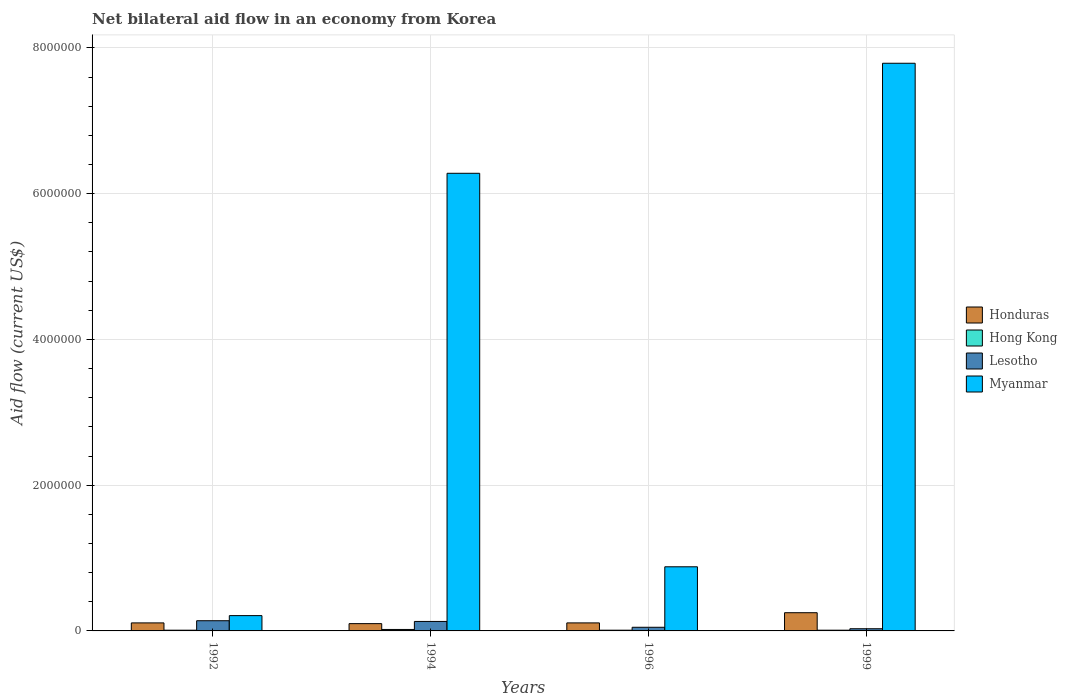How many bars are there on the 3rd tick from the left?
Ensure brevity in your answer.  4. What is the label of the 1st group of bars from the left?
Offer a terse response. 1992. What is the net bilateral aid flow in Myanmar in 1999?
Ensure brevity in your answer.  7.79e+06. Across all years, what is the minimum net bilateral aid flow in Hong Kong?
Your response must be concise. 10000. What is the total net bilateral aid flow in Hong Kong in the graph?
Give a very brief answer. 5.00e+04. What is the difference between the net bilateral aid flow in Hong Kong in 1992 and that in 1996?
Your answer should be compact. 0. What is the difference between the net bilateral aid flow in Hong Kong in 1992 and the net bilateral aid flow in Myanmar in 1999?
Make the answer very short. -7.78e+06. What is the average net bilateral aid flow in Myanmar per year?
Keep it short and to the point. 3.79e+06. What is the ratio of the net bilateral aid flow in Lesotho in 1994 to that in 1999?
Make the answer very short. 4.33. Is the net bilateral aid flow in Hong Kong in 1992 less than that in 1996?
Give a very brief answer. No. What is the difference between the highest and the second highest net bilateral aid flow in Myanmar?
Give a very brief answer. 1.51e+06. Is the sum of the net bilateral aid flow in Honduras in 1994 and 1999 greater than the maximum net bilateral aid flow in Lesotho across all years?
Your response must be concise. Yes. What does the 1st bar from the left in 1994 represents?
Give a very brief answer. Honduras. What does the 4th bar from the right in 1996 represents?
Offer a very short reply. Honduras. How many bars are there?
Make the answer very short. 16. What is the difference between two consecutive major ticks on the Y-axis?
Keep it short and to the point. 2.00e+06. Does the graph contain any zero values?
Give a very brief answer. No. Does the graph contain grids?
Offer a terse response. Yes. Where does the legend appear in the graph?
Offer a very short reply. Center right. How are the legend labels stacked?
Your answer should be very brief. Vertical. What is the title of the graph?
Your response must be concise. Net bilateral aid flow in an economy from Korea. What is the label or title of the X-axis?
Provide a succinct answer. Years. What is the label or title of the Y-axis?
Offer a terse response. Aid flow (current US$). What is the Aid flow (current US$) in Honduras in 1992?
Your answer should be very brief. 1.10e+05. What is the Aid flow (current US$) of Hong Kong in 1992?
Provide a succinct answer. 10000. What is the Aid flow (current US$) in Lesotho in 1992?
Offer a terse response. 1.40e+05. What is the Aid flow (current US$) in Myanmar in 1992?
Provide a short and direct response. 2.10e+05. What is the Aid flow (current US$) in Honduras in 1994?
Provide a succinct answer. 1.00e+05. What is the Aid flow (current US$) in Hong Kong in 1994?
Ensure brevity in your answer.  2.00e+04. What is the Aid flow (current US$) of Myanmar in 1994?
Provide a succinct answer. 6.28e+06. What is the Aid flow (current US$) in Honduras in 1996?
Keep it short and to the point. 1.10e+05. What is the Aid flow (current US$) in Lesotho in 1996?
Keep it short and to the point. 5.00e+04. What is the Aid flow (current US$) in Myanmar in 1996?
Keep it short and to the point. 8.80e+05. What is the Aid flow (current US$) in Honduras in 1999?
Your answer should be compact. 2.50e+05. What is the Aid flow (current US$) in Hong Kong in 1999?
Provide a short and direct response. 10000. What is the Aid flow (current US$) of Myanmar in 1999?
Make the answer very short. 7.79e+06. Across all years, what is the maximum Aid flow (current US$) in Honduras?
Keep it short and to the point. 2.50e+05. Across all years, what is the maximum Aid flow (current US$) of Hong Kong?
Make the answer very short. 2.00e+04. Across all years, what is the maximum Aid flow (current US$) in Myanmar?
Give a very brief answer. 7.79e+06. Across all years, what is the minimum Aid flow (current US$) in Honduras?
Provide a short and direct response. 1.00e+05. Across all years, what is the minimum Aid flow (current US$) in Hong Kong?
Give a very brief answer. 10000. Across all years, what is the minimum Aid flow (current US$) of Lesotho?
Give a very brief answer. 3.00e+04. What is the total Aid flow (current US$) in Honduras in the graph?
Keep it short and to the point. 5.70e+05. What is the total Aid flow (current US$) of Hong Kong in the graph?
Give a very brief answer. 5.00e+04. What is the total Aid flow (current US$) of Myanmar in the graph?
Offer a very short reply. 1.52e+07. What is the difference between the Aid flow (current US$) in Honduras in 1992 and that in 1994?
Give a very brief answer. 10000. What is the difference between the Aid flow (current US$) of Myanmar in 1992 and that in 1994?
Ensure brevity in your answer.  -6.07e+06. What is the difference between the Aid flow (current US$) of Hong Kong in 1992 and that in 1996?
Give a very brief answer. 0. What is the difference between the Aid flow (current US$) of Lesotho in 1992 and that in 1996?
Offer a very short reply. 9.00e+04. What is the difference between the Aid flow (current US$) of Myanmar in 1992 and that in 1996?
Offer a very short reply. -6.70e+05. What is the difference between the Aid flow (current US$) in Honduras in 1992 and that in 1999?
Your answer should be very brief. -1.40e+05. What is the difference between the Aid flow (current US$) of Myanmar in 1992 and that in 1999?
Ensure brevity in your answer.  -7.58e+06. What is the difference between the Aid flow (current US$) in Myanmar in 1994 and that in 1996?
Offer a very short reply. 5.40e+06. What is the difference between the Aid flow (current US$) of Hong Kong in 1994 and that in 1999?
Make the answer very short. 10000. What is the difference between the Aid flow (current US$) of Lesotho in 1994 and that in 1999?
Provide a succinct answer. 1.00e+05. What is the difference between the Aid flow (current US$) in Myanmar in 1994 and that in 1999?
Offer a terse response. -1.51e+06. What is the difference between the Aid flow (current US$) of Myanmar in 1996 and that in 1999?
Your answer should be compact. -6.91e+06. What is the difference between the Aid flow (current US$) in Honduras in 1992 and the Aid flow (current US$) in Hong Kong in 1994?
Ensure brevity in your answer.  9.00e+04. What is the difference between the Aid flow (current US$) in Honduras in 1992 and the Aid flow (current US$) in Lesotho in 1994?
Offer a very short reply. -2.00e+04. What is the difference between the Aid flow (current US$) of Honduras in 1992 and the Aid flow (current US$) of Myanmar in 1994?
Provide a short and direct response. -6.17e+06. What is the difference between the Aid flow (current US$) in Hong Kong in 1992 and the Aid flow (current US$) in Lesotho in 1994?
Provide a succinct answer. -1.20e+05. What is the difference between the Aid flow (current US$) in Hong Kong in 1992 and the Aid flow (current US$) in Myanmar in 1994?
Your answer should be compact. -6.27e+06. What is the difference between the Aid flow (current US$) in Lesotho in 1992 and the Aid flow (current US$) in Myanmar in 1994?
Provide a succinct answer. -6.14e+06. What is the difference between the Aid flow (current US$) in Honduras in 1992 and the Aid flow (current US$) in Hong Kong in 1996?
Your answer should be compact. 1.00e+05. What is the difference between the Aid flow (current US$) of Honduras in 1992 and the Aid flow (current US$) of Lesotho in 1996?
Ensure brevity in your answer.  6.00e+04. What is the difference between the Aid flow (current US$) in Honduras in 1992 and the Aid flow (current US$) in Myanmar in 1996?
Offer a terse response. -7.70e+05. What is the difference between the Aid flow (current US$) of Hong Kong in 1992 and the Aid flow (current US$) of Lesotho in 1996?
Provide a succinct answer. -4.00e+04. What is the difference between the Aid flow (current US$) in Hong Kong in 1992 and the Aid flow (current US$) in Myanmar in 1996?
Ensure brevity in your answer.  -8.70e+05. What is the difference between the Aid flow (current US$) in Lesotho in 1992 and the Aid flow (current US$) in Myanmar in 1996?
Give a very brief answer. -7.40e+05. What is the difference between the Aid flow (current US$) in Honduras in 1992 and the Aid flow (current US$) in Hong Kong in 1999?
Your response must be concise. 1.00e+05. What is the difference between the Aid flow (current US$) in Honduras in 1992 and the Aid flow (current US$) in Myanmar in 1999?
Your response must be concise. -7.68e+06. What is the difference between the Aid flow (current US$) in Hong Kong in 1992 and the Aid flow (current US$) in Myanmar in 1999?
Your response must be concise. -7.78e+06. What is the difference between the Aid flow (current US$) in Lesotho in 1992 and the Aid flow (current US$) in Myanmar in 1999?
Offer a very short reply. -7.65e+06. What is the difference between the Aid flow (current US$) of Honduras in 1994 and the Aid flow (current US$) of Lesotho in 1996?
Keep it short and to the point. 5.00e+04. What is the difference between the Aid flow (current US$) in Honduras in 1994 and the Aid flow (current US$) in Myanmar in 1996?
Provide a short and direct response. -7.80e+05. What is the difference between the Aid flow (current US$) of Hong Kong in 1994 and the Aid flow (current US$) of Myanmar in 1996?
Keep it short and to the point. -8.60e+05. What is the difference between the Aid flow (current US$) in Lesotho in 1994 and the Aid flow (current US$) in Myanmar in 1996?
Your response must be concise. -7.50e+05. What is the difference between the Aid flow (current US$) in Honduras in 1994 and the Aid flow (current US$) in Lesotho in 1999?
Keep it short and to the point. 7.00e+04. What is the difference between the Aid flow (current US$) in Honduras in 1994 and the Aid flow (current US$) in Myanmar in 1999?
Give a very brief answer. -7.69e+06. What is the difference between the Aid flow (current US$) of Hong Kong in 1994 and the Aid flow (current US$) of Lesotho in 1999?
Make the answer very short. -10000. What is the difference between the Aid flow (current US$) in Hong Kong in 1994 and the Aid flow (current US$) in Myanmar in 1999?
Offer a very short reply. -7.77e+06. What is the difference between the Aid flow (current US$) of Lesotho in 1994 and the Aid flow (current US$) of Myanmar in 1999?
Ensure brevity in your answer.  -7.66e+06. What is the difference between the Aid flow (current US$) in Honduras in 1996 and the Aid flow (current US$) in Hong Kong in 1999?
Keep it short and to the point. 1.00e+05. What is the difference between the Aid flow (current US$) in Honduras in 1996 and the Aid flow (current US$) in Myanmar in 1999?
Your answer should be very brief. -7.68e+06. What is the difference between the Aid flow (current US$) in Hong Kong in 1996 and the Aid flow (current US$) in Lesotho in 1999?
Keep it short and to the point. -2.00e+04. What is the difference between the Aid flow (current US$) in Hong Kong in 1996 and the Aid flow (current US$) in Myanmar in 1999?
Ensure brevity in your answer.  -7.78e+06. What is the difference between the Aid flow (current US$) in Lesotho in 1996 and the Aid flow (current US$) in Myanmar in 1999?
Offer a very short reply. -7.74e+06. What is the average Aid flow (current US$) in Honduras per year?
Your response must be concise. 1.42e+05. What is the average Aid flow (current US$) of Hong Kong per year?
Provide a succinct answer. 1.25e+04. What is the average Aid flow (current US$) of Lesotho per year?
Ensure brevity in your answer.  8.75e+04. What is the average Aid flow (current US$) of Myanmar per year?
Offer a very short reply. 3.79e+06. In the year 1992, what is the difference between the Aid flow (current US$) of Honduras and Aid flow (current US$) of Hong Kong?
Offer a very short reply. 1.00e+05. In the year 1992, what is the difference between the Aid flow (current US$) in Honduras and Aid flow (current US$) in Lesotho?
Give a very brief answer. -3.00e+04. In the year 1992, what is the difference between the Aid flow (current US$) in Hong Kong and Aid flow (current US$) in Lesotho?
Make the answer very short. -1.30e+05. In the year 1992, what is the difference between the Aid flow (current US$) of Hong Kong and Aid flow (current US$) of Myanmar?
Offer a terse response. -2.00e+05. In the year 1994, what is the difference between the Aid flow (current US$) of Honduras and Aid flow (current US$) of Myanmar?
Provide a succinct answer. -6.18e+06. In the year 1994, what is the difference between the Aid flow (current US$) of Hong Kong and Aid flow (current US$) of Myanmar?
Make the answer very short. -6.26e+06. In the year 1994, what is the difference between the Aid flow (current US$) of Lesotho and Aid flow (current US$) of Myanmar?
Give a very brief answer. -6.15e+06. In the year 1996, what is the difference between the Aid flow (current US$) in Honduras and Aid flow (current US$) in Lesotho?
Your answer should be very brief. 6.00e+04. In the year 1996, what is the difference between the Aid flow (current US$) of Honduras and Aid flow (current US$) of Myanmar?
Your answer should be very brief. -7.70e+05. In the year 1996, what is the difference between the Aid flow (current US$) in Hong Kong and Aid flow (current US$) in Myanmar?
Your answer should be compact. -8.70e+05. In the year 1996, what is the difference between the Aid flow (current US$) in Lesotho and Aid flow (current US$) in Myanmar?
Keep it short and to the point. -8.30e+05. In the year 1999, what is the difference between the Aid flow (current US$) of Honduras and Aid flow (current US$) of Myanmar?
Keep it short and to the point. -7.54e+06. In the year 1999, what is the difference between the Aid flow (current US$) of Hong Kong and Aid flow (current US$) of Myanmar?
Offer a very short reply. -7.78e+06. In the year 1999, what is the difference between the Aid flow (current US$) in Lesotho and Aid flow (current US$) in Myanmar?
Give a very brief answer. -7.76e+06. What is the ratio of the Aid flow (current US$) in Honduras in 1992 to that in 1994?
Keep it short and to the point. 1.1. What is the ratio of the Aid flow (current US$) in Myanmar in 1992 to that in 1994?
Keep it short and to the point. 0.03. What is the ratio of the Aid flow (current US$) of Honduras in 1992 to that in 1996?
Keep it short and to the point. 1. What is the ratio of the Aid flow (current US$) in Hong Kong in 1992 to that in 1996?
Offer a terse response. 1. What is the ratio of the Aid flow (current US$) of Lesotho in 1992 to that in 1996?
Keep it short and to the point. 2.8. What is the ratio of the Aid flow (current US$) of Myanmar in 1992 to that in 1996?
Your answer should be very brief. 0.24. What is the ratio of the Aid flow (current US$) of Honduras in 1992 to that in 1999?
Offer a very short reply. 0.44. What is the ratio of the Aid flow (current US$) in Hong Kong in 1992 to that in 1999?
Keep it short and to the point. 1. What is the ratio of the Aid flow (current US$) of Lesotho in 1992 to that in 1999?
Make the answer very short. 4.67. What is the ratio of the Aid flow (current US$) in Myanmar in 1992 to that in 1999?
Provide a succinct answer. 0.03. What is the ratio of the Aid flow (current US$) of Honduras in 1994 to that in 1996?
Ensure brevity in your answer.  0.91. What is the ratio of the Aid flow (current US$) in Hong Kong in 1994 to that in 1996?
Offer a very short reply. 2. What is the ratio of the Aid flow (current US$) in Myanmar in 1994 to that in 1996?
Keep it short and to the point. 7.14. What is the ratio of the Aid flow (current US$) of Lesotho in 1994 to that in 1999?
Your answer should be very brief. 4.33. What is the ratio of the Aid flow (current US$) of Myanmar in 1994 to that in 1999?
Offer a terse response. 0.81. What is the ratio of the Aid flow (current US$) in Honduras in 1996 to that in 1999?
Provide a short and direct response. 0.44. What is the ratio of the Aid flow (current US$) of Myanmar in 1996 to that in 1999?
Your response must be concise. 0.11. What is the difference between the highest and the second highest Aid flow (current US$) in Honduras?
Keep it short and to the point. 1.40e+05. What is the difference between the highest and the second highest Aid flow (current US$) in Hong Kong?
Your response must be concise. 10000. What is the difference between the highest and the second highest Aid flow (current US$) in Lesotho?
Provide a short and direct response. 10000. What is the difference between the highest and the second highest Aid flow (current US$) of Myanmar?
Your answer should be compact. 1.51e+06. What is the difference between the highest and the lowest Aid flow (current US$) in Lesotho?
Keep it short and to the point. 1.10e+05. What is the difference between the highest and the lowest Aid flow (current US$) in Myanmar?
Keep it short and to the point. 7.58e+06. 